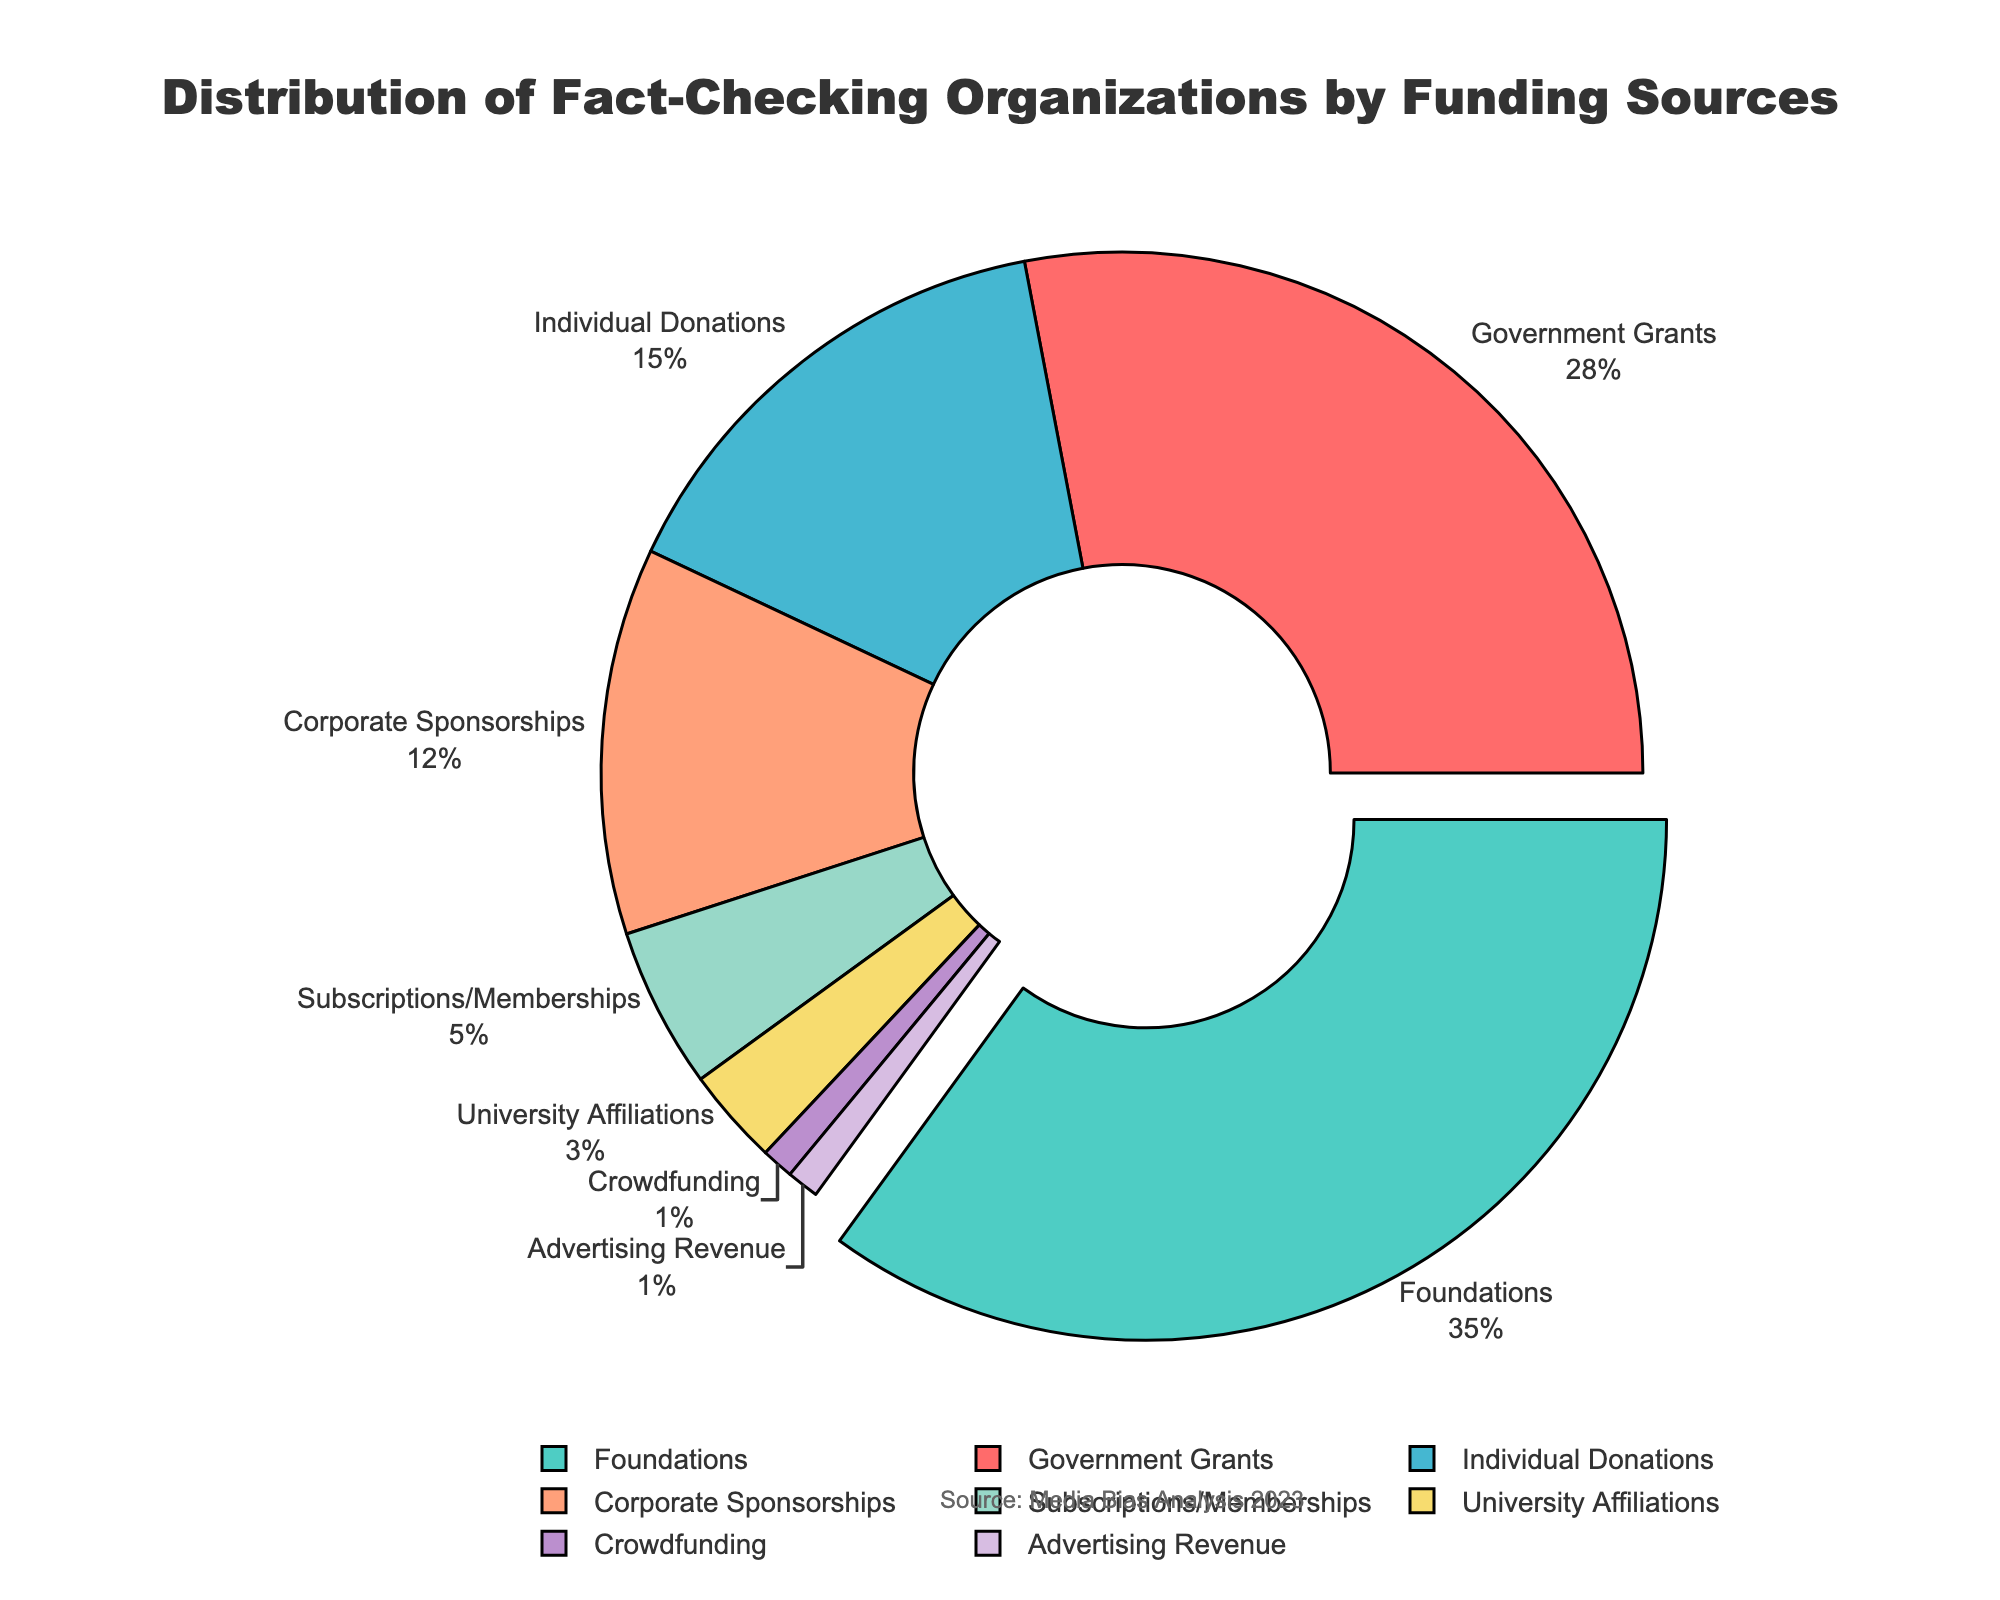What is the most common funding source for fact-checking organizations? The pie chart shows that foundations have the highest percentage at 35%, making it the most common funding source.
Answer: Foundations What is the combined percentage of funding from government grants and corporate sponsorships? Government grants account for 28% and corporate sponsorships for 12%. Adding them together gives 28% + 12% = 40%.
Answer: 40% How does the percentage of individual donations compare to university affiliations? The pie chart shows individual donations at 15% and university affiliations at 3%. Therefore, individual donations are greater than university affiliations.
Answer: Individual donations are greater What's the percentage difference between the highest and lowest funding sources? The highest funding source is foundations at 35%, and the lowest are crowdfunding and advertising revenue at 1% each. The difference is 35% - 1% = 34%.
Answer: 34% If you combine the funding sources with the smallest percentages (advertising revenue and crowdfunding), what do you get? Both advertising revenue and crowdfunding are 1%. Adding them together gives 1% + 1% = 2%.
Answer: 2% Which funding sources are less than 10% of the total? From the chart, subscriptions/memberships (5%), university affiliations (3%), crowdfunding (1%), and advertising revenue (1%) are all below 10%.
Answer: Subscriptions/Memberships, University Affiliations, Crowdfunding, Advertising Revenue What visual feature is used to highlight the most common funding source? The pie chart uses a 'pull' effect to separate the largest segment (foundations) slightly from the rest of the pie to emphasize its importance.
Answer: Pull effect Which funding source has a visual emphasis by being pulled out from the chart? The chart pulls out the foundation funding source segment, emphasizing it's the largest at 35%.
Answer: Foundations Is the percentage of funding from individual donations greater than from corporate sponsorships? The chart shows individual donations at 15% and corporate sponsorships at 12%. Therefore, individual donations are greater.
Answer: Yes What is the second smallest funding source, and what is its percentage? Crowdfunding and advertising revenue are both at 1%, making them the smallest. The second smallest is university affiliations at 3%.
Answer: University affiliations, 3% 